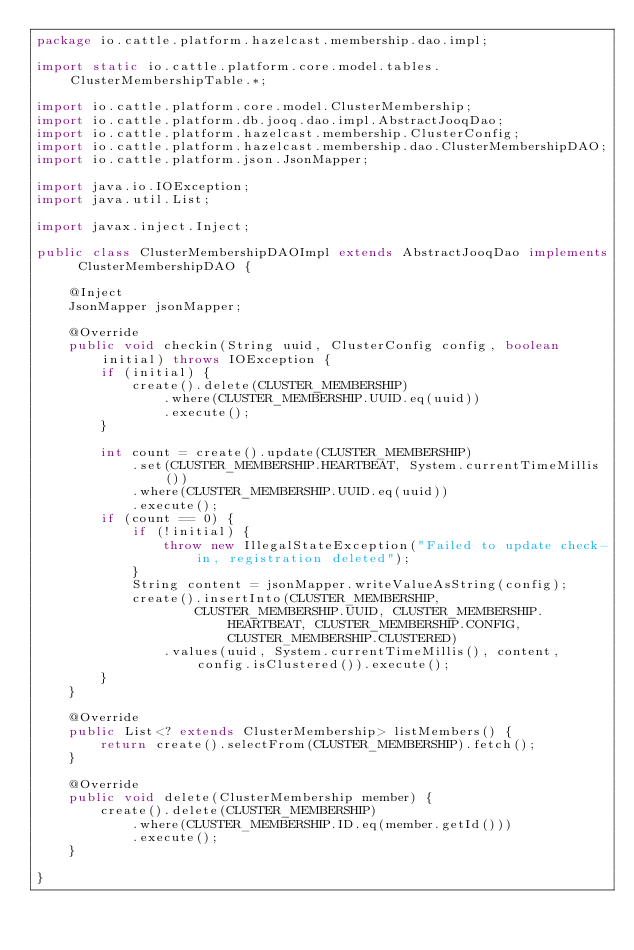Convert code to text. <code><loc_0><loc_0><loc_500><loc_500><_Java_>package io.cattle.platform.hazelcast.membership.dao.impl;

import static io.cattle.platform.core.model.tables.ClusterMembershipTable.*;

import io.cattle.platform.core.model.ClusterMembership;
import io.cattle.platform.db.jooq.dao.impl.AbstractJooqDao;
import io.cattle.platform.hazelcast.membership.ClusterConfig;
import io.cattle.platform.hazelcast.membership.dao.ClusterMembershipDAO;
import io.cattle.platform.json.JsonMapper;

import java.io.IOException;
import java.util.List;

import javax.inject.Inject;

public class ClusterMembershipDAOImpl extends AbstractJooqDao implements ClusterMembershipDAO {

    @Inject
    JsonMapper jsonMapper;

    @Override
    public void checkin(String uuid, ClusterConfig config, boolean initial) throws IOException {
        if (initial) {
            create().delete(CLUSTER_MEMBERSHIP)
                .where(CLUSTER_MEMBERSHIP.UUID.eq(uuid))
                .execute();
        }

        int count = create().update(CLUSTER_MEMBERSHIP)
            .set(CLUSTER_MEMBERSHIP.HEARTBEAT, System.currentTimeMillis())
            .where(CLUSTER_MEMBERSHIP.UUID.eq(uuid))
            .execute();
        if (count == 0) {
            if (!initial) {
                throw new IllegalStateException("Failed to update check-in, registration deleted");
            }
            String content = jsonMapper.writeValueAsString(config);
            create().insertInto(CLUSTER_MEMBERSHIP,
                    CLUSTER_MEMBERSHIP.UUID, CLUSTER_MEMBERSHIP.HEARTBEAT, CLUSTER_MEMBERSHIP.CONFIG, CLUSTER_MEMBERSHIP.CLUSTERED)
                .values(uuid, System.currentTimeMillis(), content, config.isClustered()).execute();
        }
    }

    @Override
    public List<? extends ClusterMembership> listMembers() {
        return create().selectFrom(CLUSTER_MEMBERSHIP).fetch();
    }

    @Override
    public void delete(ClusterMembership member) {
        create().delete(CLUSTER_MEMBERSHIP)
            .where(CLUSTER_MEMBERSHIP.ID.eq(member.getId()))
            .execute();
    }

}
</code> 